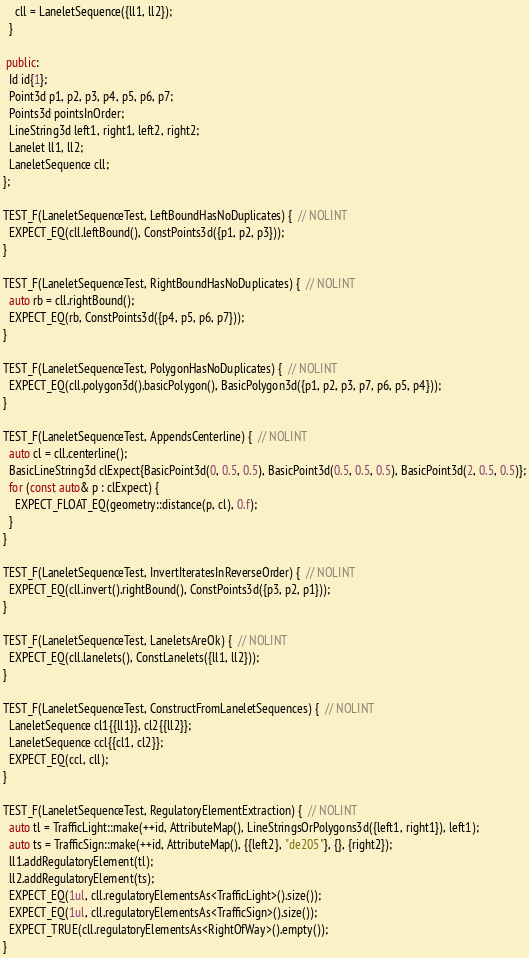Convert code to text. <code><loc_0><loc_0><loc_500><loc_500><_C++_>    cll = LaneletSequence({ll1, ll2});
  }

 public:
  Id id{1};
  Point3d p1, p2, p3, p4, p5, p6, p7;
  Points3d pointsInOrder;
  LineString3d left1, right1, left2, right2;
  Lanelet ll1, ll2;
  LaneletSequence cll;
};

TEST_F(LaneletSequenceTest, LeftBoundHasNoDuplicates) {  // NOLINT
  EXPECT_EQ(cll.leftBound(), ConstPoints3d({p1, p2, p3}));
}

TEST_F(LaneletSequenceTest, RightBoundHasNoDuplicates) {  // NOLINT
  auto rb = cll.rightBound();
  EXPECT_EQ(rb, ConstPoints3d({p4, p5, p6, p7}));
}

TEST_F(LaneletSequenceTest, PolygonHasNoDuplicates) {  // NOLINT
  EXPECT_EQ(cll.polygon3d().basicPolygon(), BasicPolygon3d({p1, p2, p3, p7, p6, p5, p4}));
}

TEST_F(LaneletSequenceTest, AppendsCenterline) {  // NOLINT
  auto cl = cll.centerline();
  BasicLineString3d clExpect{BasicPoint3d(0, 0.5, 0.5), BasicPoint3d(0.5, 0.5, 0.5), BasicPoint3d(2, 0.5, 0.5)};
  for (const auto& p : clExpect) {
    EXPECT_FLOAT_EQ(geometry::distance(p, cl), 0.f);
  }
}

TEST_F(LaneletSequenceTest, InvertIteratesInReverseOrder) {  // NOLINT
  EXPECT_EQ(cll.invert().rightBound(), ConstPoints3d({p3, p2, p1}));
}

TEST_F(LaneletSequenceTest, LaneletsAreOk) {  // NOLINT
  EXPECT_EQ(cll.lanelets(), ConstLanelets({ll1, ll2}));
}

TEST_F(LaneletSequenceTest, ConstructFromLaneletSequences) {  // NOLINT
  LaneletSequence cl1{{ll1}}, cl2{{ll2}};
  LaneletSequence ccl{{cl1, cl2}};
  EXPECT_EQ(ccl, cll);
}

TEST_F(LaneletSequenceTest, RegulatoryElementExtraction) {  // NOLINT
  auto tl = TrafficLight::make(++id, AttributeMap(), LineStringsOrPolygons3d({left1, right1}), left1);
  auto ts = TrafficSign::make(++id, AttributeMap(), {{left2}, "de205"}, {}, {right2});
  ll1.addRegulatoryElement(tl);
  ll2.addRegulatoryElement(ts);
  EXPECT_EQ(1ul, cll.regulatoryElementsAs<TrafficLight>().size());
  EXPECT_EQ(1ul, cll.regulatoryElementsAs<TrafficSign>().size());
  EXPECT_TRUE(cll.regulatoryElementsAs<RightOfWay>().empty());
}
</code> 